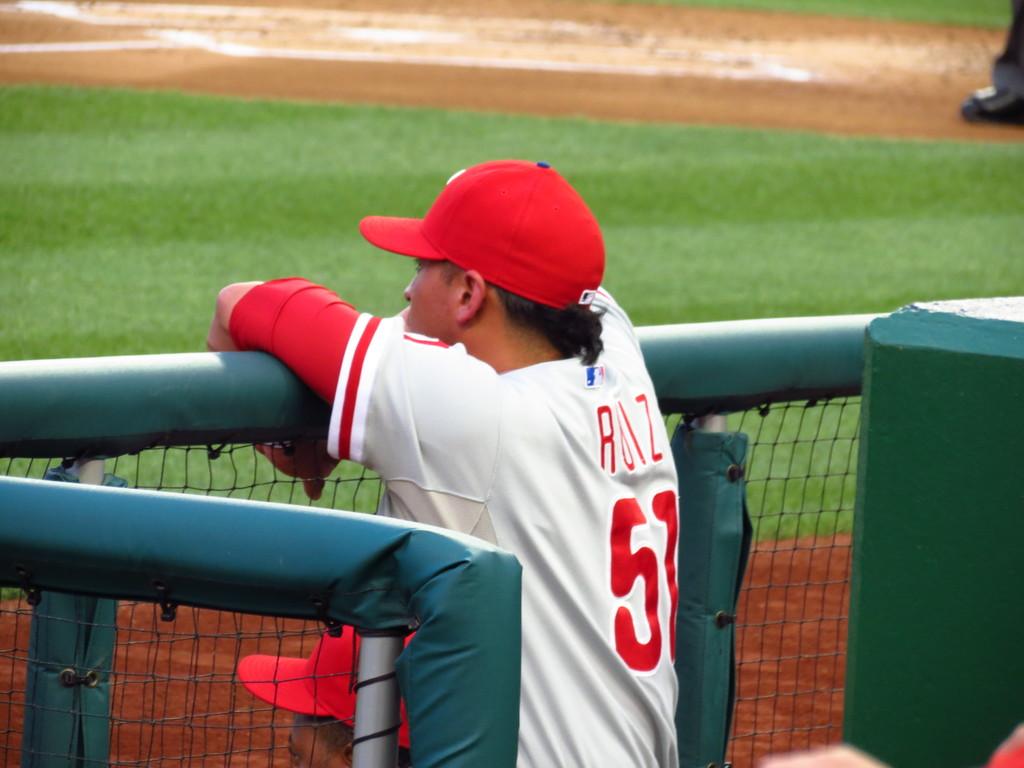What letter does his last name start with?
Your response must be concise. R. What is the number on the shirt?
Your answer should be compact. 51. 